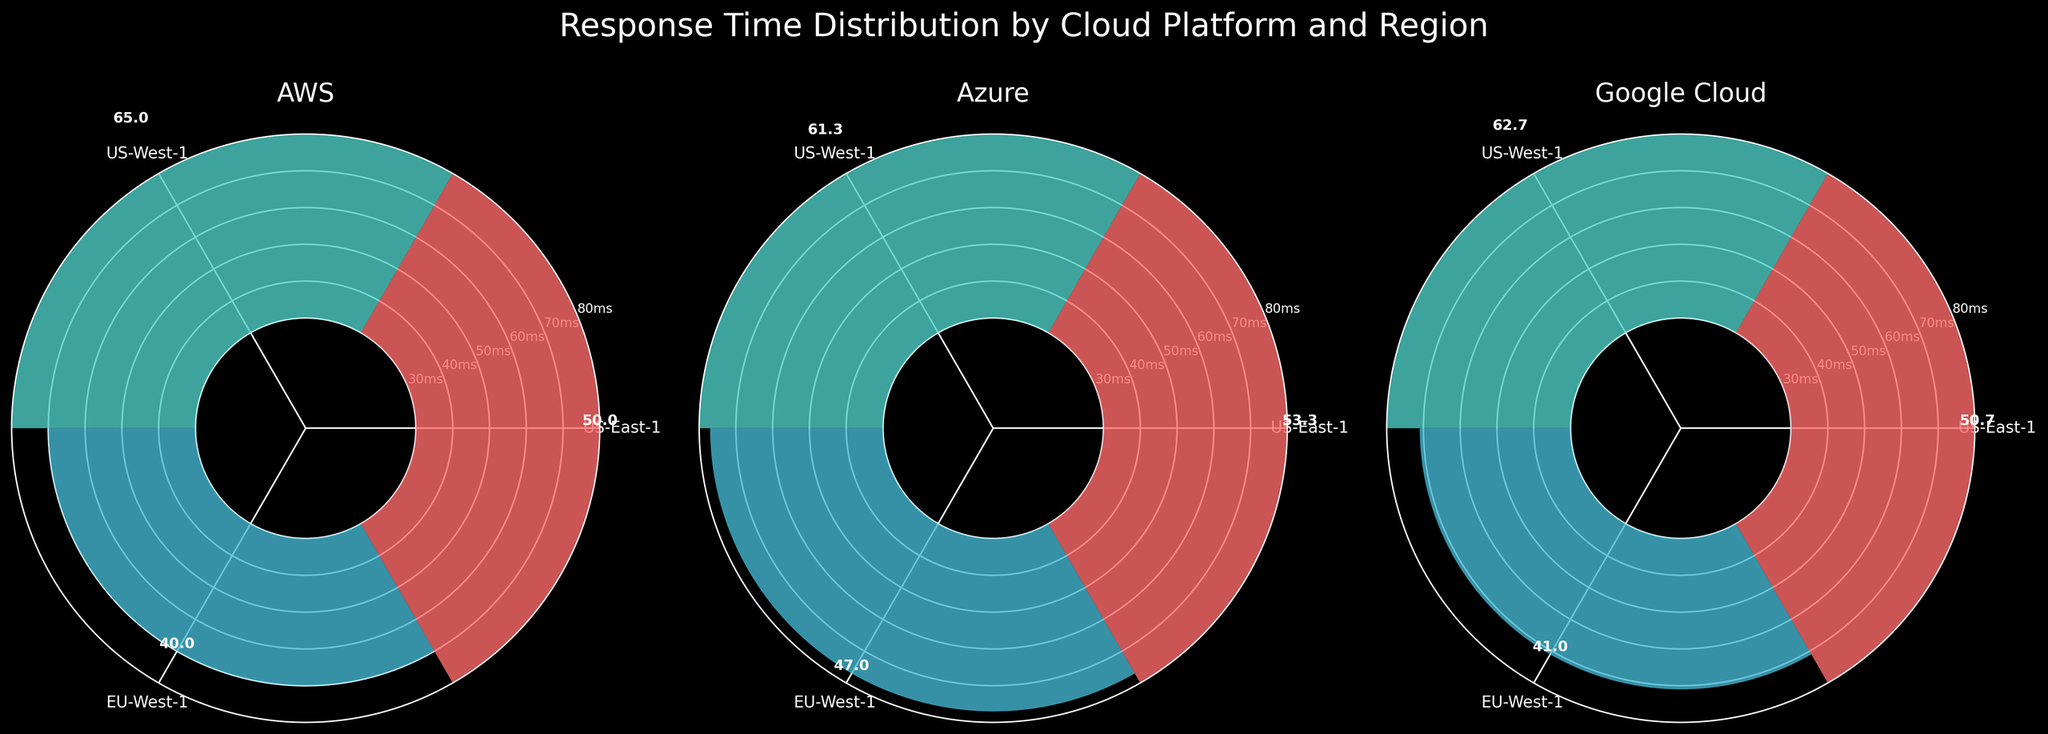Which platform has the highest response time in the US-East-1 region? Look at the bars corresponding to the US-East-1 region for each platform and identify the highest bar. For US-East-1, Google Cloud has the highest average response time.
Answer: Google Cloud What is the average response time for AWS in the EU-West-1 region? Locate the bar for AWS in the EU-West-1 region and read the value directly from the labeled bars. The value is around 40 ms.
Answer: 40 ms Which region shows the lowest average response time for Azure? Compare the heights of the bars for Azure across all regions. The EU-West-1 region has the lowest average response time for Azure.
Answer: EU-West-1 Compare the average response times of Google Cloud and Azure in the US-West-1 region. Which platform is faster? Locate the bars for both Google Cloud and Azure in the US-West-1 region and compare their heights. Google's bar is taller than Azure's, indicating Google Cloud has a higher average response time, so Azure is faster.
Answer: Azure How many regions are compared in the plot? Count the number of distinct bars in one subplot or count the number of unique ticks. The regions are US-East-1, US-West-1, and EU-West-1, making a total of three regions.
Answer: 3 regions Which cloud platform has the most consistent response times across all regions? Compare the variation in the heights of bars within each platform subplot. AWS shows the least variation in bar heights across regions.
Answer: AWS What's the average response time for all Azure bars combined? First, note the response times from each Azure region: US-East-1 (53.3), US-West-1 (61.3), EU-West-1 (47). Then calculate their average: (53.3 + 61.3 + 47) / 3 = 53.87 ms.
Answer: 53.87 ms Is the average response time in US-West-1 higher than in EU-West-1 for all platforms? Compare the heights of bars for each platform between US-West-1 and EU-West-1. For AWS, Azure, and Google Cloud, the US-West-1 bars are all higher than their EU-West-1 counterparts, indicating higher response times.
Answer: Yes 